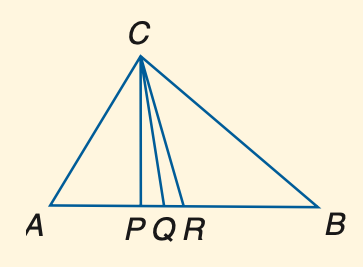Answer the mathemtical geometry problem and directly provide the correct option letter.
Question: In the figure, C P is an altitude, C Q is the angle bisector of \angle A C B, and R is the midpoint of A B. Find A B if A R = 3 x + 6 and R B = 5 x - 14.
Choices: A: 66 B: 68 C: 70 D: 72 D 